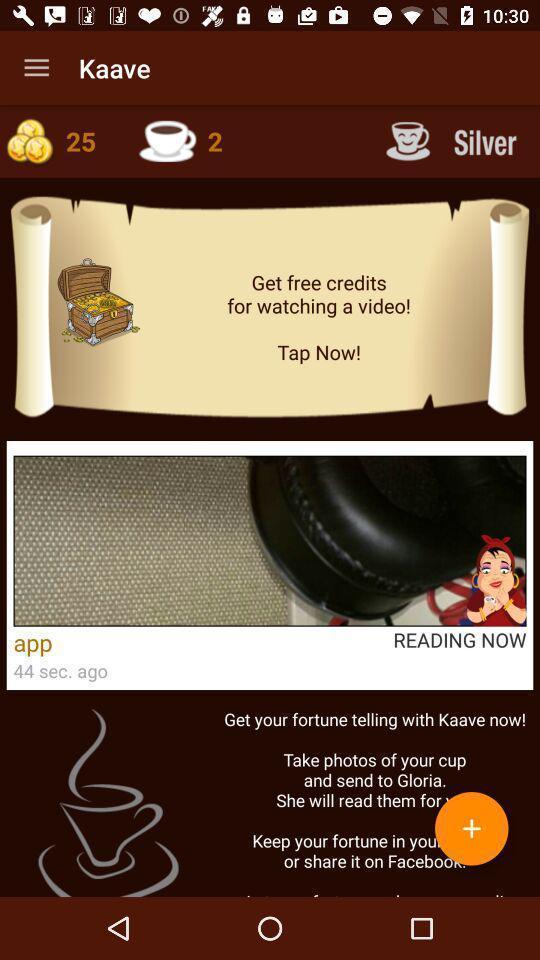Tell me about the visual elements in this screen capture. Page of a tasseography application. 